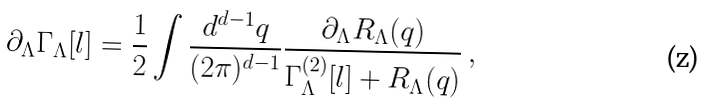<formula> <loc_0><loc_0><loc_500><loc_500>\partial _ { \Lambda } \Gamma _ { \Lambda } [ l ] = \frac { 1 } { 2 } \int \frac { d ^ { d - 1 } q } { ( 2 \pi ) ^ { d - 1 } } \frac { \partial _ { \Lambda } R _ { \Lambda } ( q ) } { \Gamma _ { \Lambda } ^ { ( 2 ) } [ l ] + R _ { \Lambda } ( q ) } \, ,</formula> 